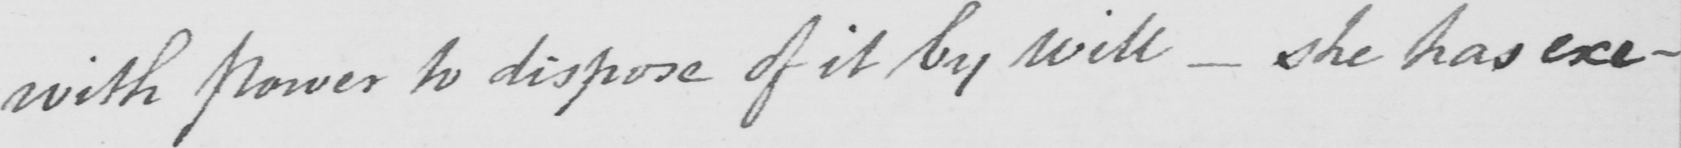Please provide the text content of this handwritten line. with power to dispose of it by will  _  she has exe- 